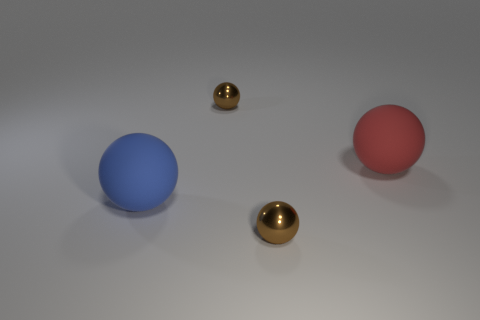Does the red rubber object have the same size as the metal object that is behind the big red object?
Provide a succinct answer. No. How many other objects are the same material as the large blue ball?
Your response must be concise. 1. What is the shape of the object that is behind the big blue rubber thing and left of the red ball?
Provide a short and direct response. Sphere. There is a brown thing that is behind the large red rubber ball; does it have the same size as the brown shiny sphere that is in front of the red rubber sphere?
Your answer should be very brief. Yes. There is a red thing that is the same material as the blue sphere; what shape is it?
Provide a succinct answer. Sphere. There is a thing that is to the left of the small object that is behind the brown thing that is in front of the large red ball; what color is it?
Your answer should be very brief. Blue. Are there fewer small brown objects in front of the blue rubber thing than objects that are in front of the large red matte thing?
Give a very brief answer. Yes. Do the large red rubber thing and the blue thing have the same shape?
Your response must be concise. Yes. How many matte objects have the same size as the red rubber ball?
Keep it short and to the point. 1. Is the number of matte objects that are on the left side of the blue matte ball less than the number of big rubber things?
Ensure brevity in your answer.  Yes. 